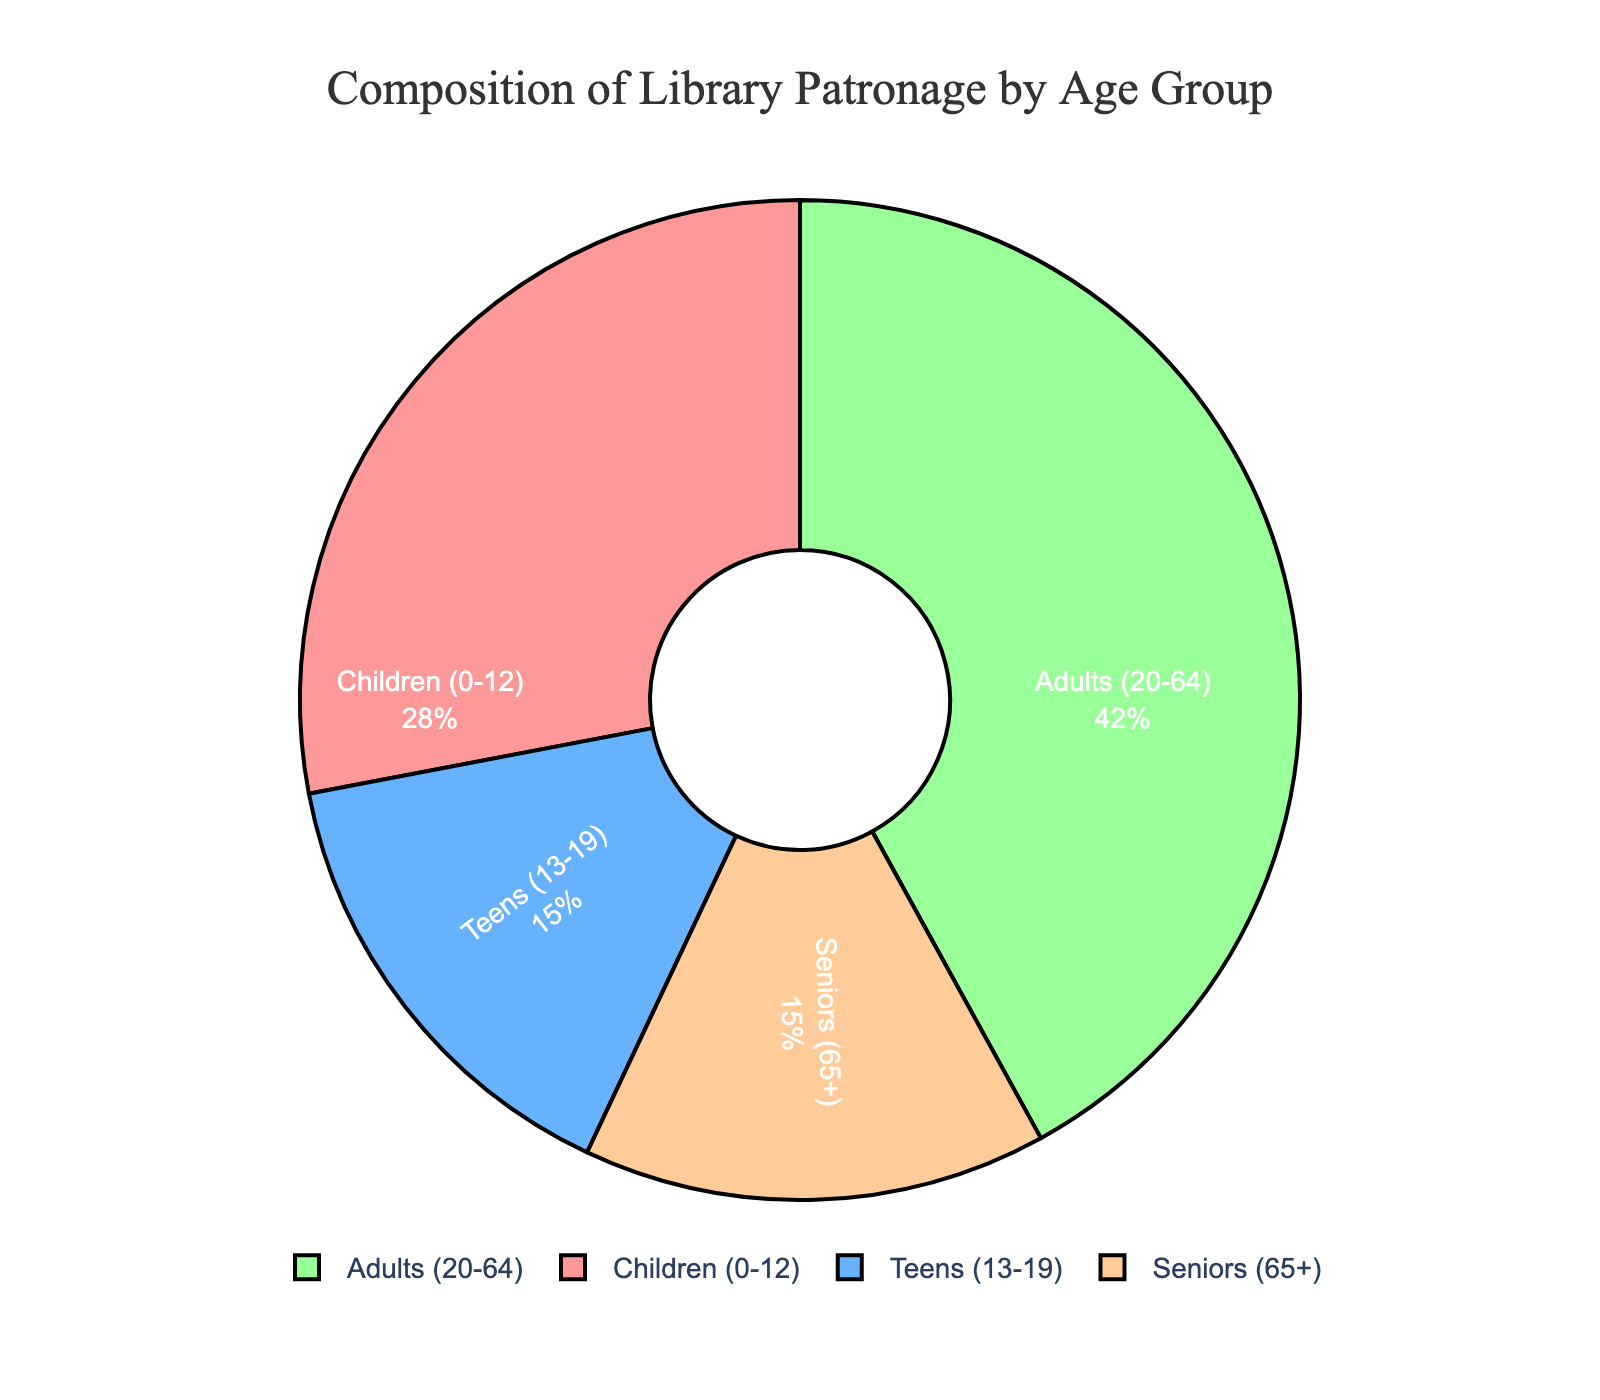What is the title of the figure? The title of the figure is displayed at the top of the plot. It reads "Economic Indicators of European Union NUTS Regions."
Answer: Economic Indicators of European Union NUTS Regions Which subplot shows the relationship between GDP per Capita and Unemployment Rate? The subplot titles are displayed above each subplot. The left subplot is titled "GDP per Capita vs Unemployment Rate" which indicates it shows the relationship between GDP per Capita and Unemployment Rate.
Answer: The left subplot What information is shown by the size of the bubbles in the left subplot? The size of the bubbles in the left subplot is proportional to the scaled population of each region. Larger bubbles represent regions with larger populations.
Answer: Population Which NUTS region has the highest GDP per Capita in the right subplot? On the right subplot, find the bubble highest on the y-axis (GDP per Capita). The region with the highest GDP per Capita is Southern and Eastern, Ireland.
Answer: Southern and Eastern, Ireland Which region has the smallest Unemployment Rate and what is its GDP per Capita? Find the smallest value on the x-axis (Unemployment Rate) in the left subplot, then identify the corresponding bubble. The region is Bucuresti-Ilfov, Romania, and its GDP per Capita is 25,000 euros.
Answer: Bucuresti-Ilfov, Romania, 25,000 euros How does the Unemployment Rate relate to GDP per Capita in the left subplot? In the left subplot, observe the overall trend between the x-axis (Unemployment Rate) and y-axis (GDP per Capita). There is no clear direct relationship; regions with lower unemployment rates do not necessarily have higher GDP per Capita, and vice versa.
Answer: No clear relationship Which country has the widest range of colors in the right subplot? Colors in the right subplot indicate Unemployment Rates. Comparing the color diversity across regions, France (Île de France) exhibits multiple distinct colors within the plot.
Answer: France How does Population scale with bubbles in the right subplot? In the right subplot, the x-axis represents the Population with a logarithmic scale. The bubbles’ sizes indicate Unemployment Rate, and not population, thus size influences color indication directly.
Answer: Logarithmic scale Identify the region with the highest population and its GDP per Capita in the right subplot. In the right subplot, find the bubble farthest to the right along x-axis (Population). The region is Île de France, France, with a GDP per Capita of 59,000 euros.
Answer: Île de France, France, 59,000 euros Which region has the highest Unemployment Rate and what is its GDP per Capita? In the left subplot, find the bubble farthest to the right along x-axis (Unemployment Rate). The region is Cataluña, Spain, and its GDP per Capita is 32,000 euros.
Answer: Cataluña, Spain, 32,000 euros 